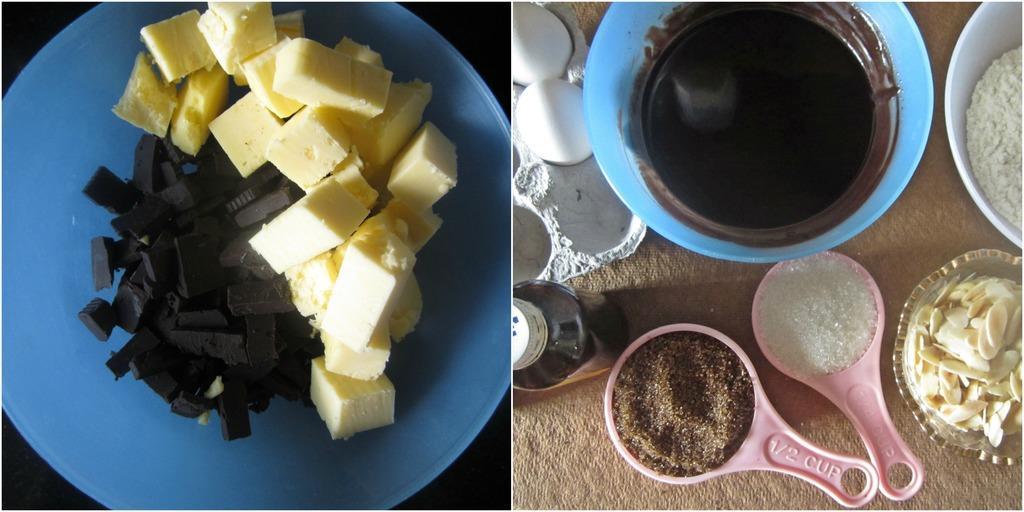How would you summarize this image in a sentence or two? This is a collage image. We can see some food items in containers. In the second part of the image, we can see some eggs in a tray, a bottle. We can see some tea strainers with sugar and other object. 